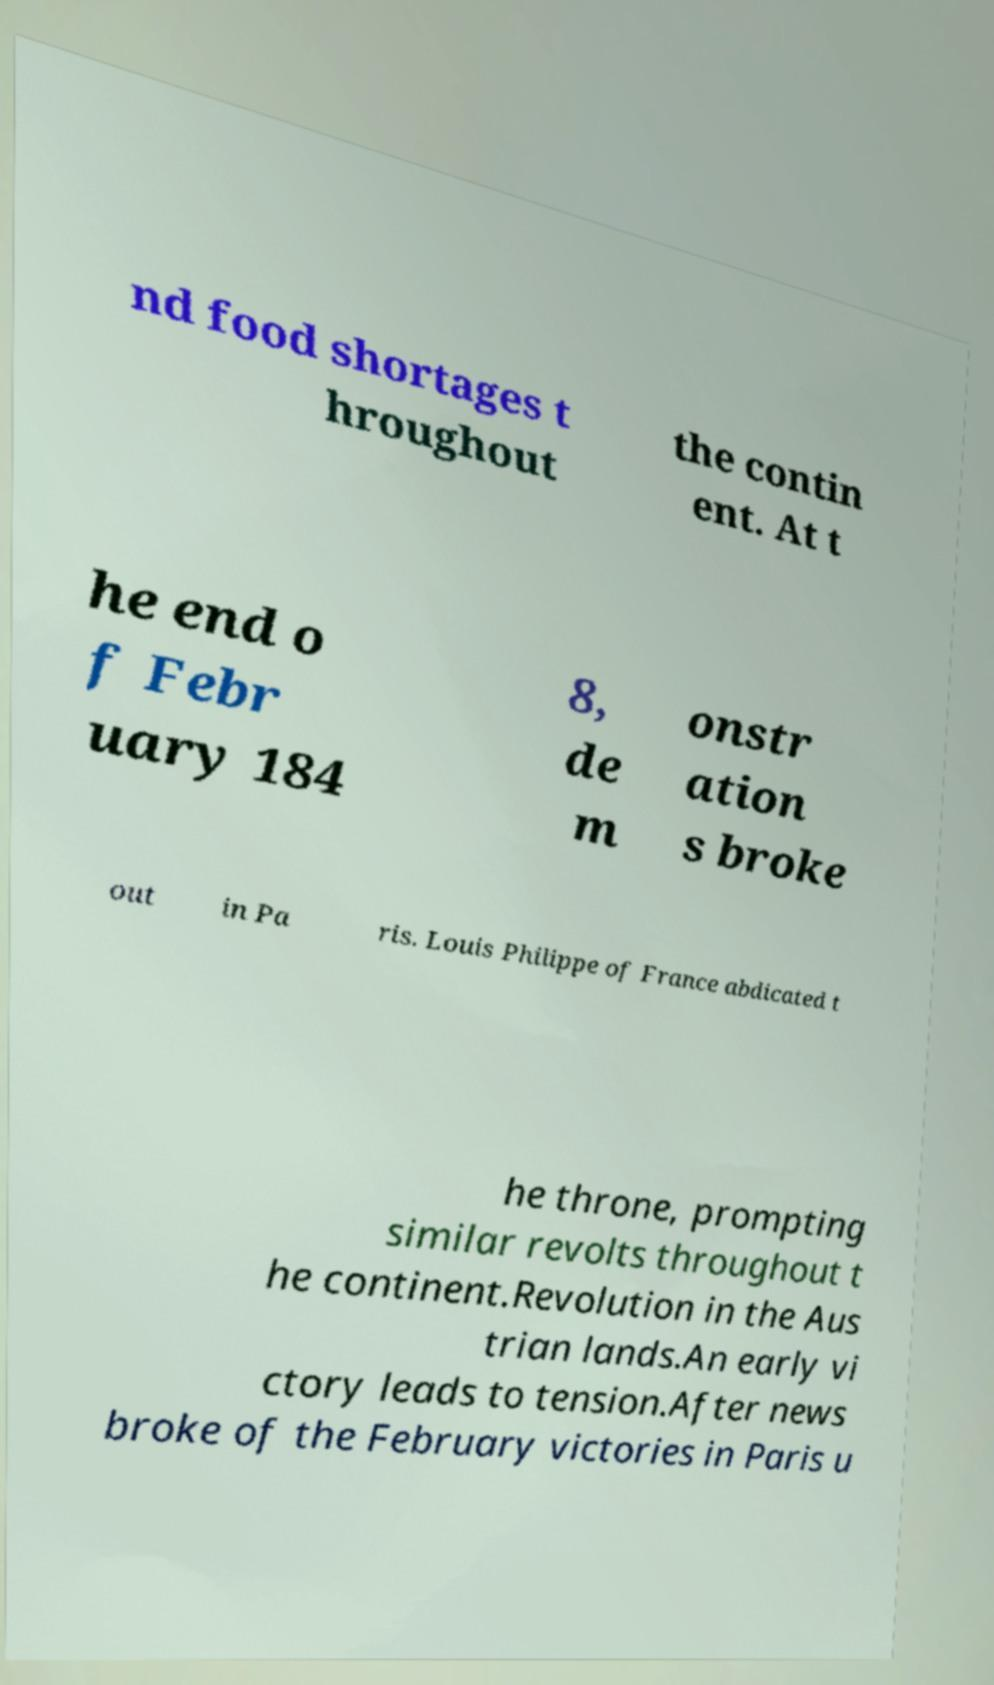Can you accurately transcribe the text from the provided image for me? nd food shortages t hroughout the contin ent. At t he end o f Febr uary 184 8, de m onstr ation s broke out in Pa ris. Louis Philippe of France abdicated t he throne, prompting similar revolts throughout t he continent.Revolution in the Aus trian lands.An early vi ctory leads to tension.After news broke of the February victories in Paris u 